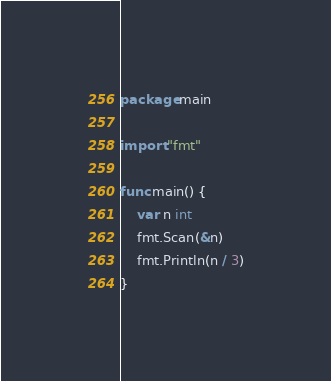Convert code to text. <code><loc_0><loc_0><loc_500><loc_500><_Go_>package main

import "fmt"

func main() {
	var n int
	fmt.Scan(&n)
	fmt.Println(n / 3)
}
</code> 